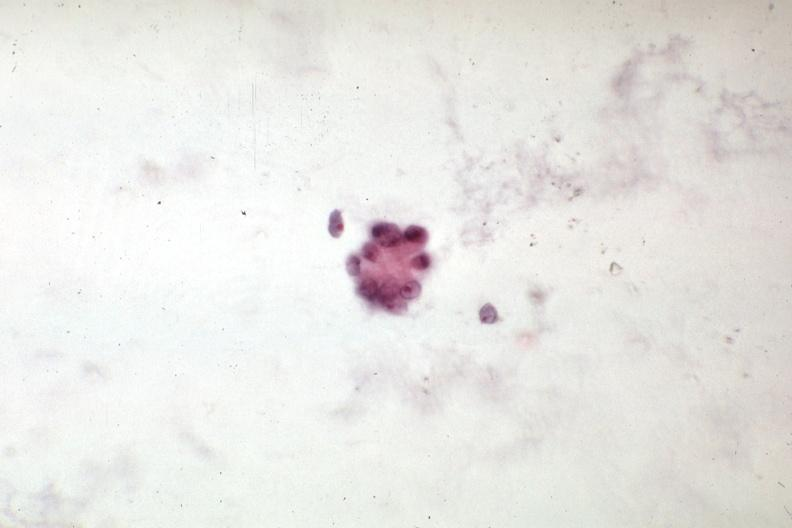does this image show malignant cells mixed mesodermal tumor of uterus?
Answer the question using a single word or phrase. Yes 